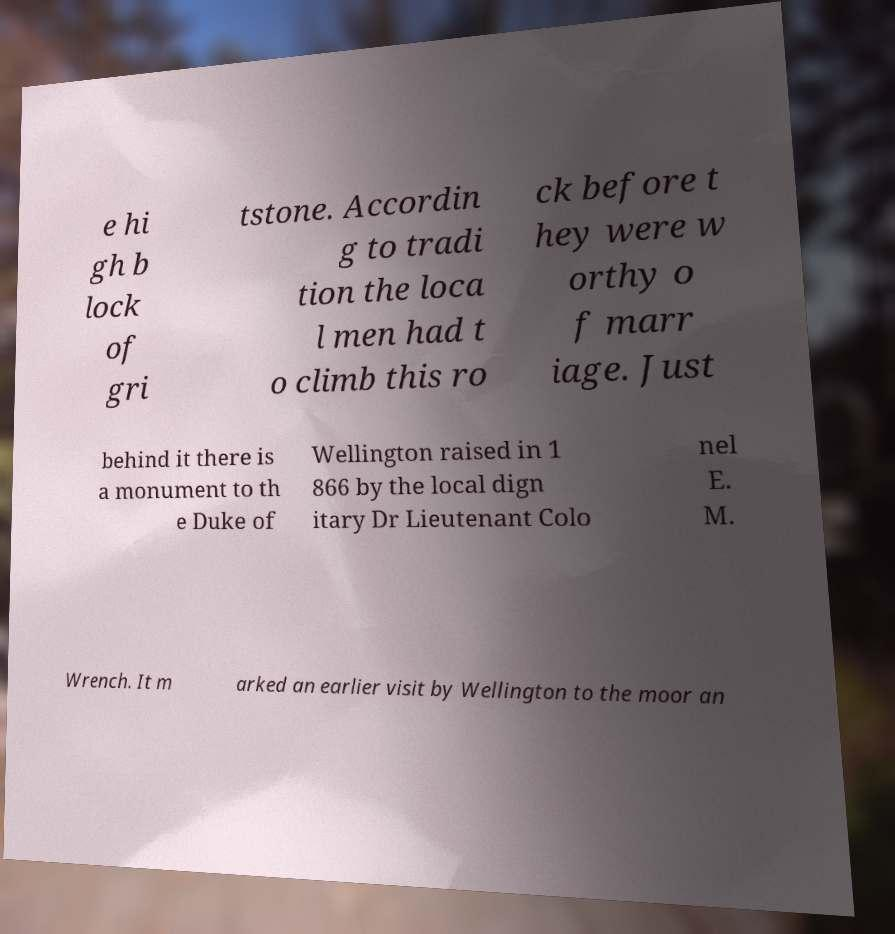Please read and relay the text visible in this image. What does it say? e hi gh b lock of gri tstone. Accordin g to tradi tion the loca l men had t o climb this ro ck before t hey were w orthy o f marr iage. Just behind it there is a monument to th e Duke of Wellington raised in 1 866 by the local dign itary Dr Lieutenant Colo nel E. M. Wrench. It m arked an earlier visit by Wellington to the moor an 